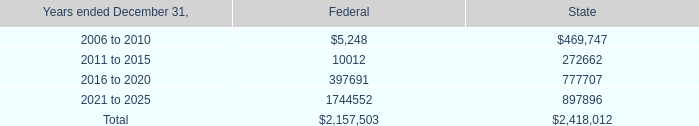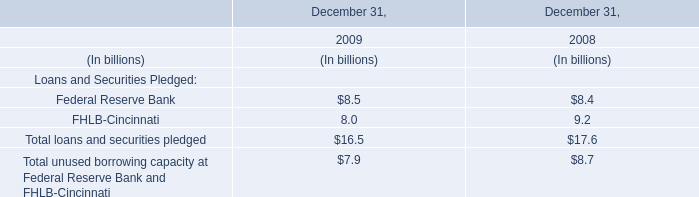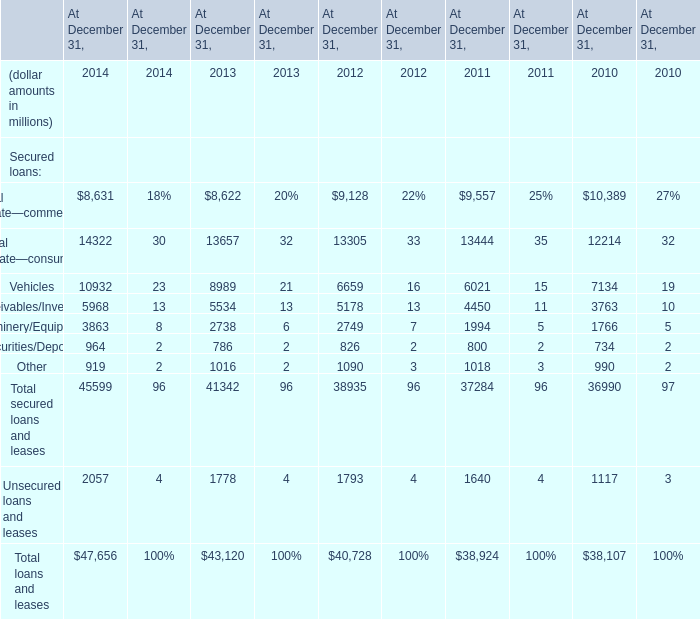What's the average of Receivables/Inventory of At December 31, 2013, and 2016 to 2020 of State ? 
Computations: ((5534.0 + 777707.0) / 2)
Answer: 391620.5. 